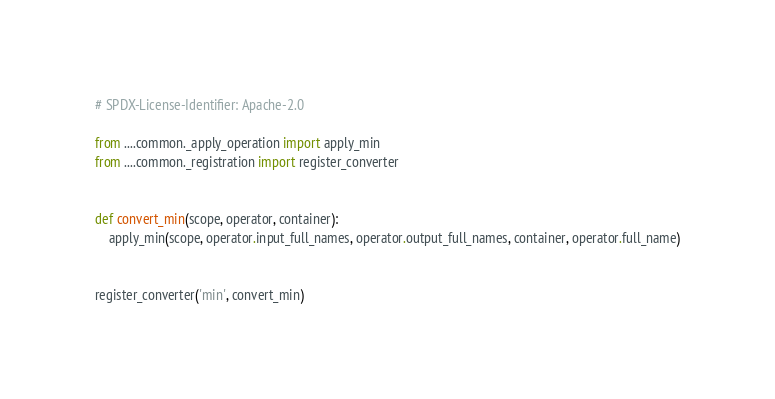Convert code to text. <code><loc_0><loc_0><loc_500><loc_500><_Python_># SPDX-License-Identifier: Apache-2.0

from ....common._apply_operation import apply_min
from ....common._registration import register_converter


def convert_min(scope, operator, container):
    apply_min(scope, operator.input_full_names, operator.output_full_names, container, operator.full_name)


register_converter('min', convert_min)
</code> 